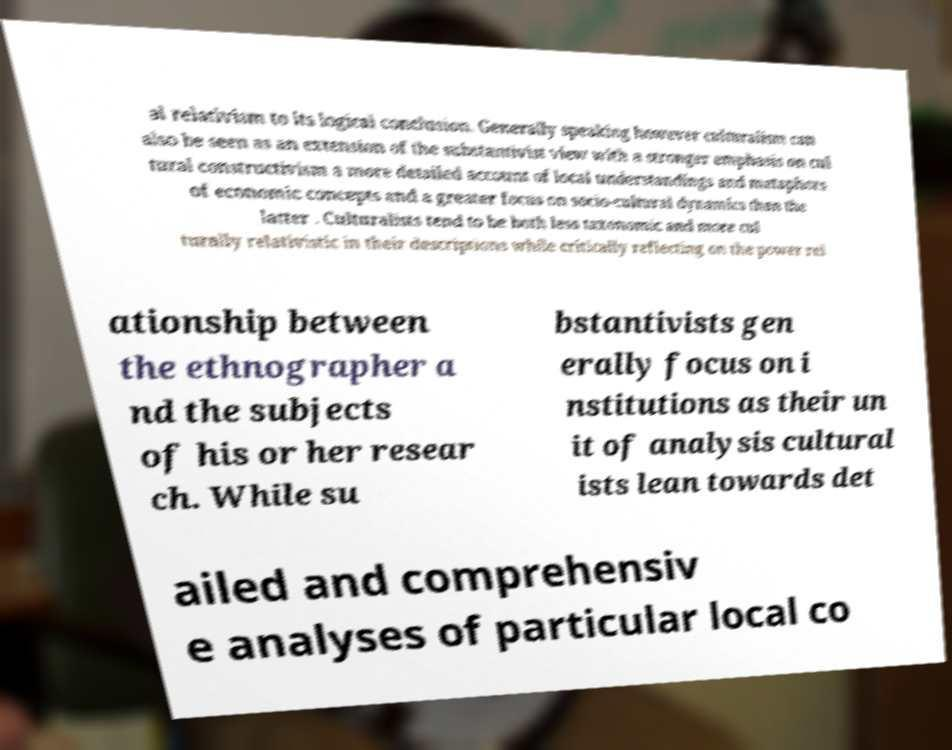I need the written content from this picture converted into text. Can you do that? al relativism to its logical conclusion. Generally speaking however culturalism can also be seen as an extension of the substantivist view with a stronger emphasis on cul tural constructivism a more detailed account of local understandings and metaphors of economic concepts and a greater focus on socio-cultural dynamics than the latter . Culturalists tend to be both less taxonomic and more cul turally relativistic in their descriptions while critically reflecting on the power rel ationship between the ethnographer a nd the subjects of his or her resear ch. While su bstantivists gen erally focus on i nstitutions as their un it of analysis cultural ists lean towards det ailed and comprehensiv e analyses of particular local co 